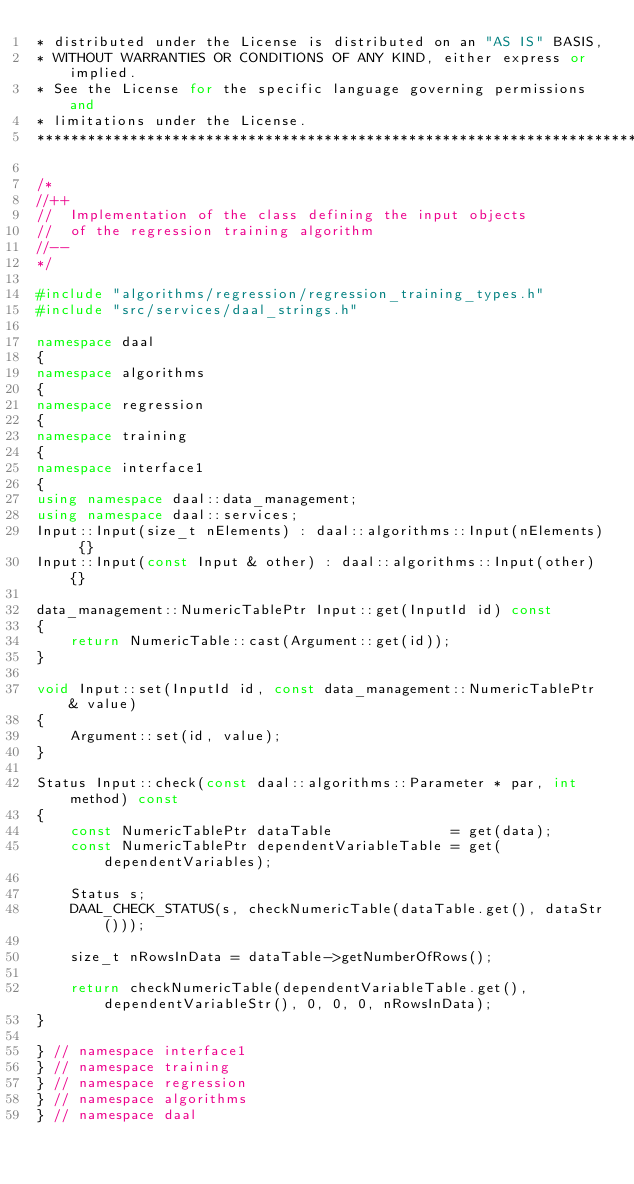Convert code to text. <code><loc_0><loc_0><loc_500><loc_500><_C++_>* distributed under the License is distributed on an "AS IS" BASIS,
* WITHOUT WARRANTIES OR CONDITIONS OF ANY KIND, either express or implied.
* See the License for the specific language governing permissions and
* limitations under the License.
*******************************************************************************/

/*
//++
//  Implementation of the class defining the input objects
//  of the regression training algorithm
//--
*/

#include "algorithms/regression/regression_training_types.h"
#include "src/services/daal_strings.h"

namespace daal
{
namespace algorithms
{
namespace regression
{
namespace training
{
namespace interface1
{
using namespace daal::data_management;
using namespace daal::services;
Input::Input(size_t nElements) : daal::algorithms::Input(nElements) {}
Input::Input(const Input & other) : daal::algorithms::Input(other) {}

data_management::NumericTablePtr Input::get(InputId id) const
{
    return NumericTable::cast(Argument::get(id));
}

void Input::set(InputId id, const data_management::NumericTablePtr & value)
{
    Argument::set(id, value);
}

Status Input::check(const daal::algorithms::Parameter * par, int method) const
{
    const NumericTablePtr dataTable              = get(data);
    const NumericTablePtr dependentVariableTable = get(dependentVariables);

    Status s;
    DAAL_CHECK_STATUS(s, checkNumericTable(dataTable.get(), dataStr()));

    size_t nRowsInData = dataTable->getNumberOfRows();

    return checkNumericTable(dependentVariableTable.get(), dependentVariableStr(), 0, 0, 0, nRowsInData);
}

} // namespace interface1
} // namespace training
} // namespace regression
} // namespace algorithms
} // namespace daal
</code> 